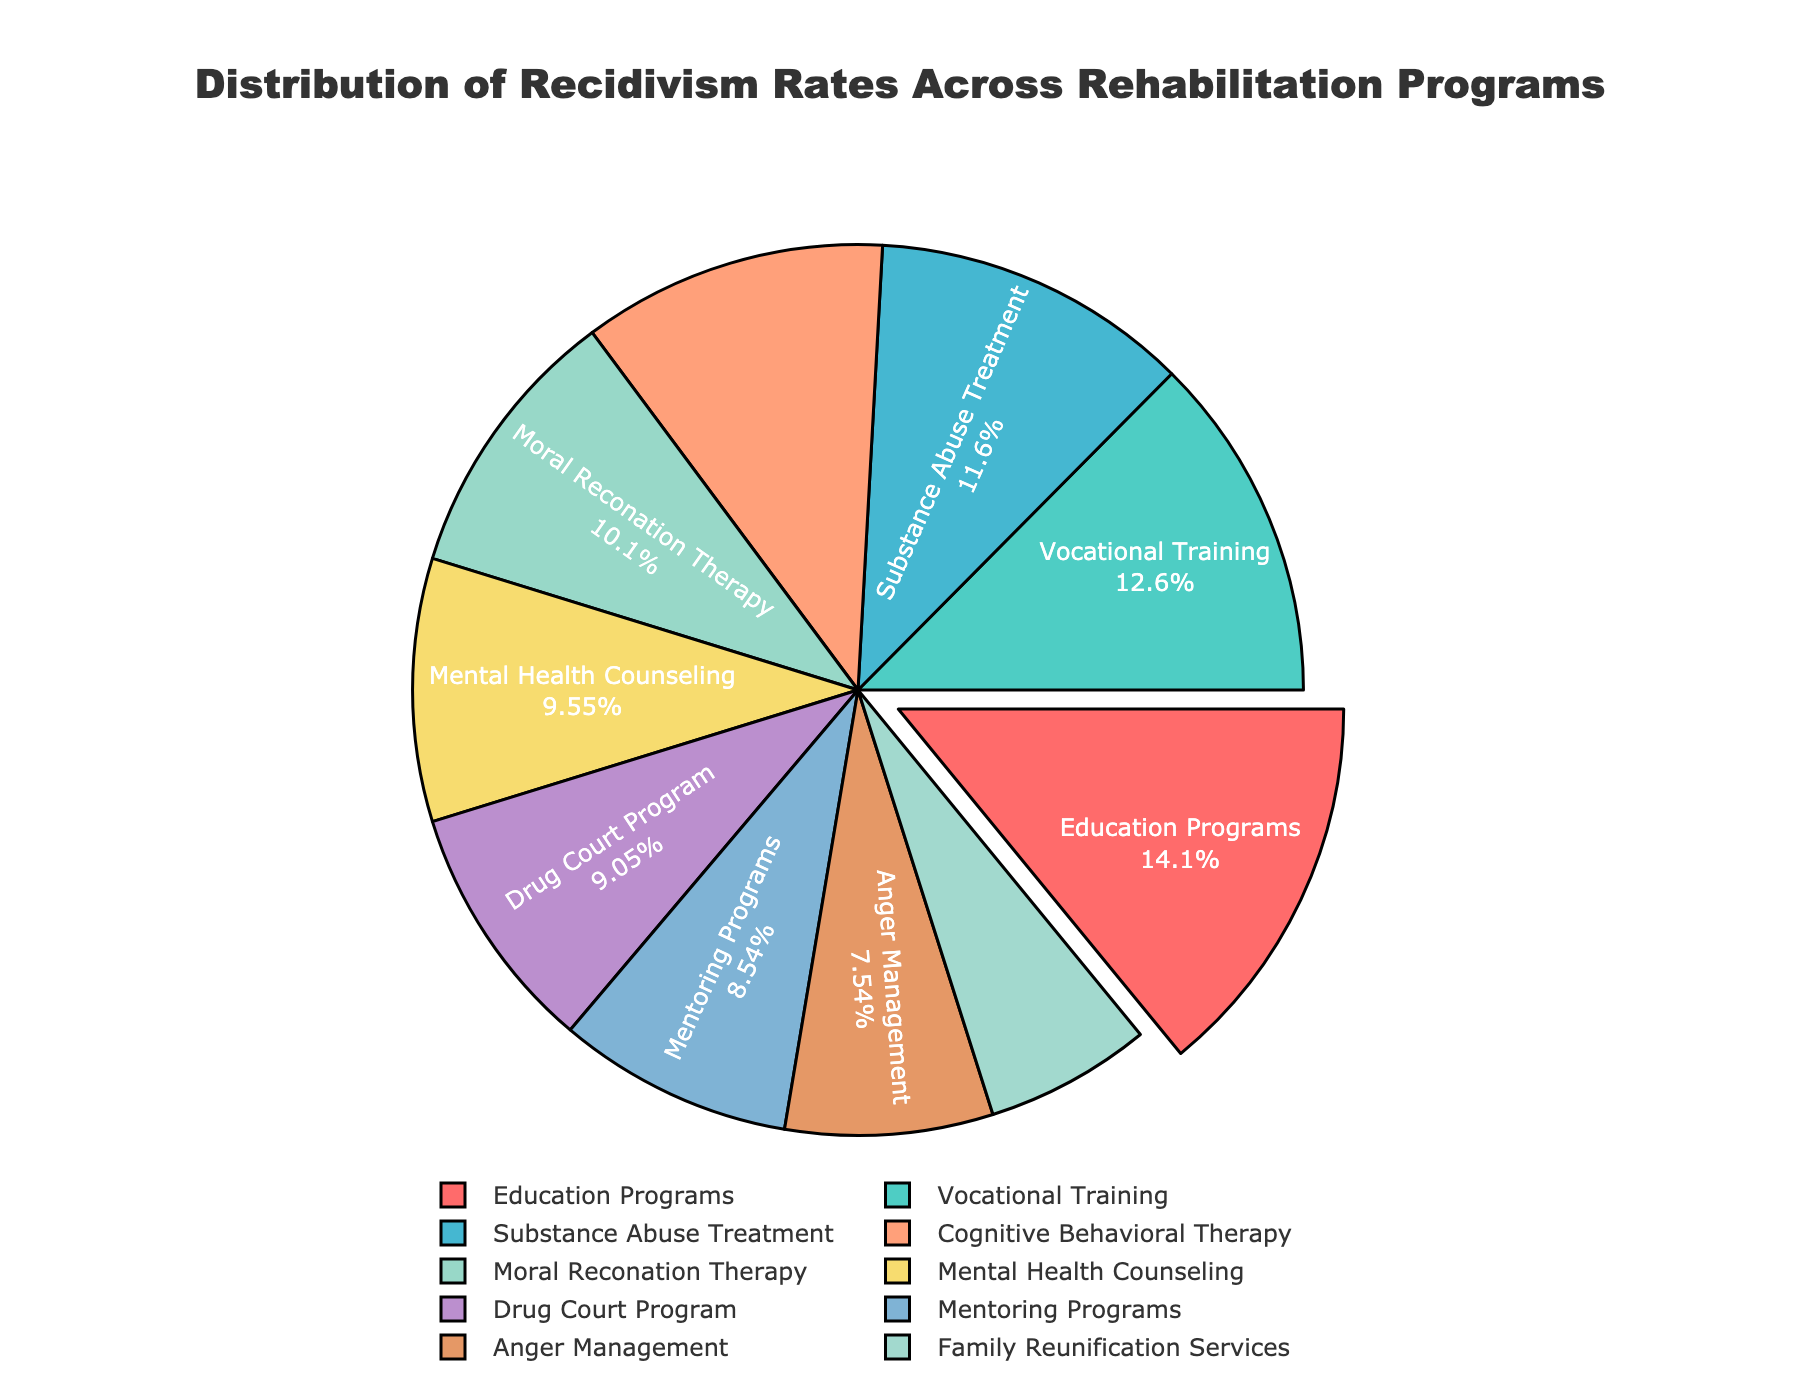What programs have higher recidivism rates than Drug Court Program? First, identify the recidivism rate of the Drug Court Program, which is 18%. Then, look at the programs with rates higher than this.
Answer: Cognitive Behavioral Therapy, Vocational Training, Education Programs, Substance Abuse Treatment Which program has the lowest recidivism rate? Identify the program with the smallest value in recidivism rates.
Answer: Family Reunification Services What is the combined recidivism rate of Cognitive Behavioral Therapy and Education Programs? The recidivism rate for Cognitive Behavioral Therapy is 22%, and for Education Programs, it is 28%. Adding them together gives 22% + 28% = 50%.
Answer: 50% Which program has the largest recidivism rate percentage in the pie chart? The program with the highest numerical recidivism rate is identified.
Answer: Education Programs What is the difference in recidivism rates between Anger Management and Cognitive Behavioral Therapy? The recidivism rate for Anger Management is 15%, and for Cognitive Behavioral Therapy, it is 22%. The difference is 22% - 15% = 7%.
Answer: 7% What proportion of the total recidivism rate does Mental Health Counseling represent? Divide the recidivism rate of Mental Health Counseling (19%) by the total recidivism rate, then multiply by 100 for percentage.
Answer: 10.1% Which section occupying the red color in the pie chart corresponds to which program? Identify the program that matches the red-colored section in the pie chart.
Answer: Cognitive Behavioral Therapy Are there more programs with a recidivism rate above or below 20%? Count the number of programs with recidivism rates above and below 20% and compare.
Answer: Below 